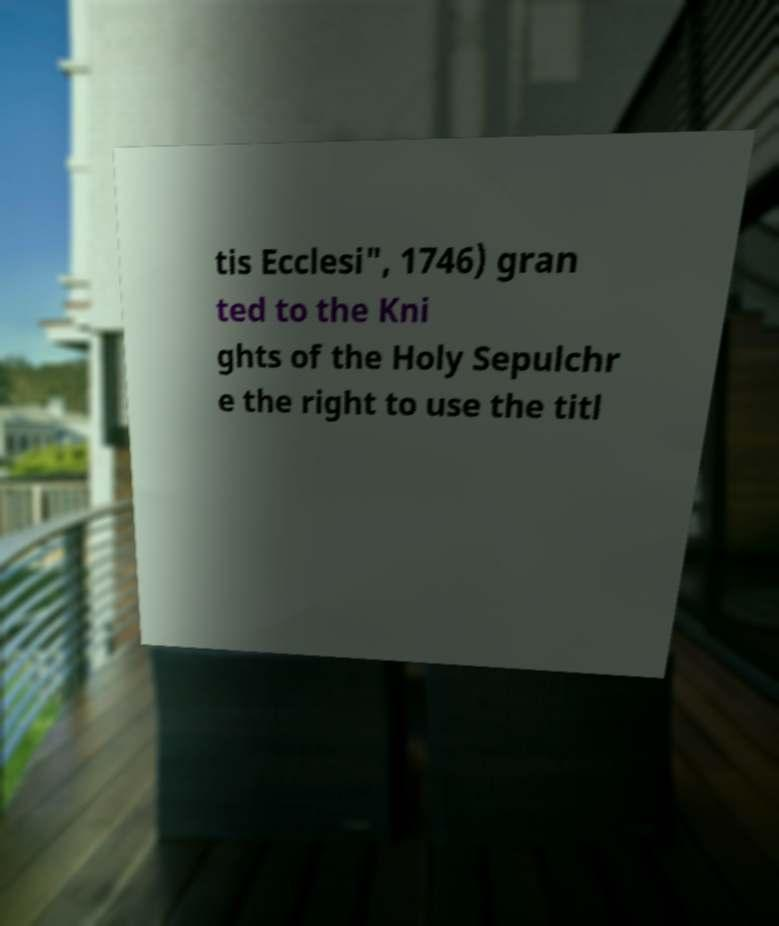Can you accurately transcribe the text from the provided image for me? tis Ecclesi", 1746) gran ted to the Kni ghts of the Holy Sepulchr e the right to use the titl 